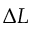Convert formula to latex. <formula><loc_0><loc_0><loc_500><loc_500>\Delta L</formula> 